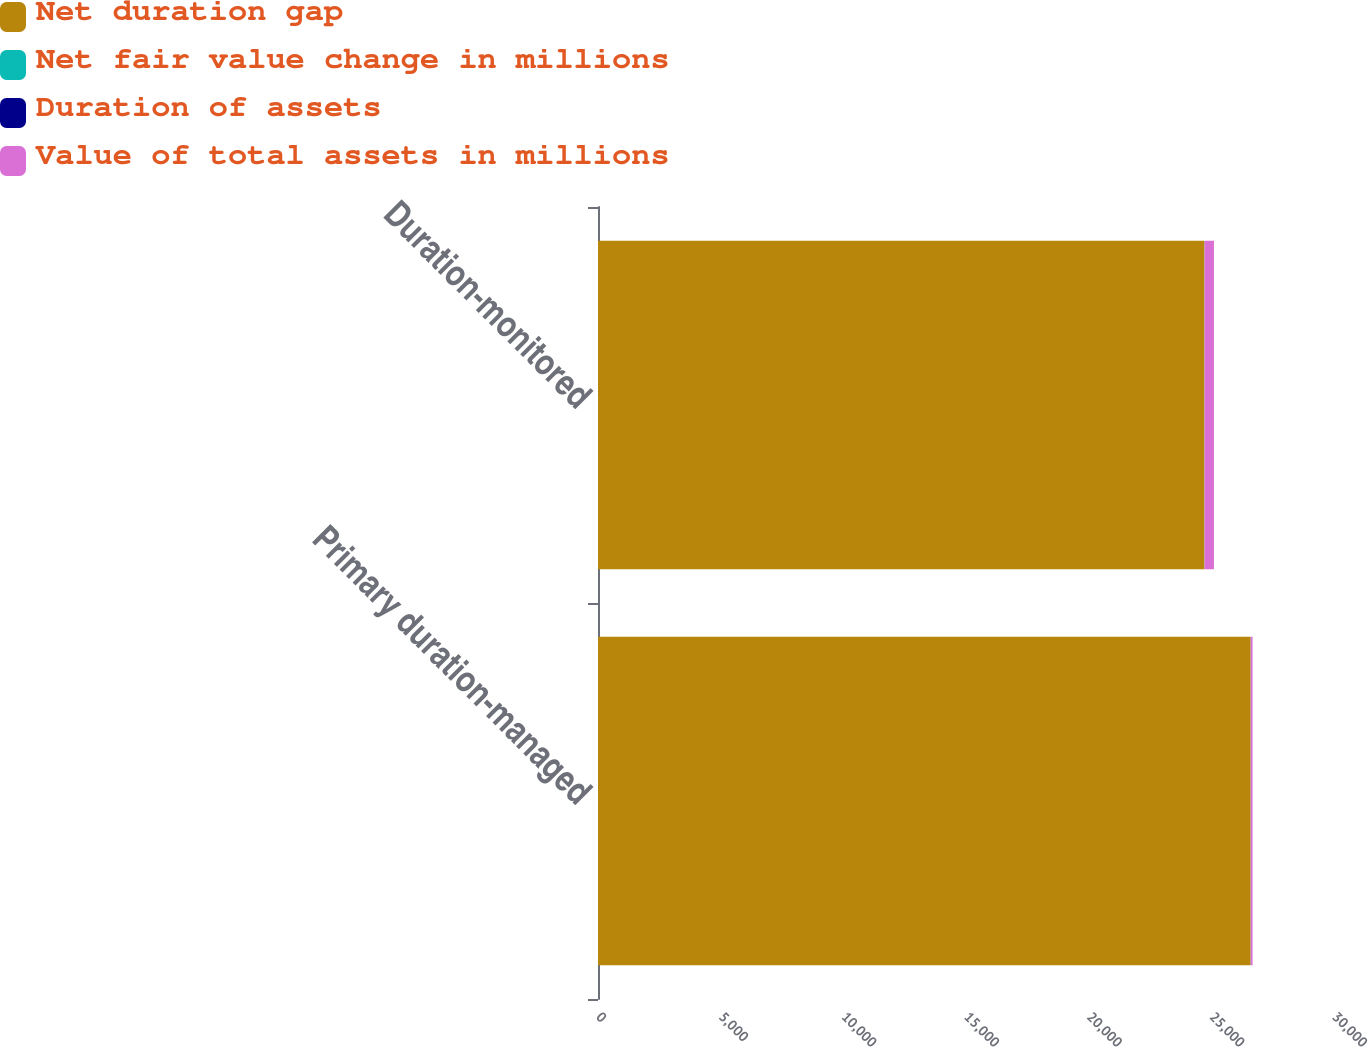Convert chart. <chart><loc_0><loc_0><loc_500><loc_500><stacked_bar_chart><ecel><fcel>Primary duration-managed<fcel>Duration-monitored<nl><fcel>Net duration gap<fcel>26601.9<fcel>24720<nl><fcel>Net fair value change in millions<fcel>3.53<fcel>4.18<nl><fcel>Duration of assets<fcel>0.28<fcel>1.54<nl><fcel>Value of total assets in millions<fcel>74.5<fcel>380.9<nl></chart> 